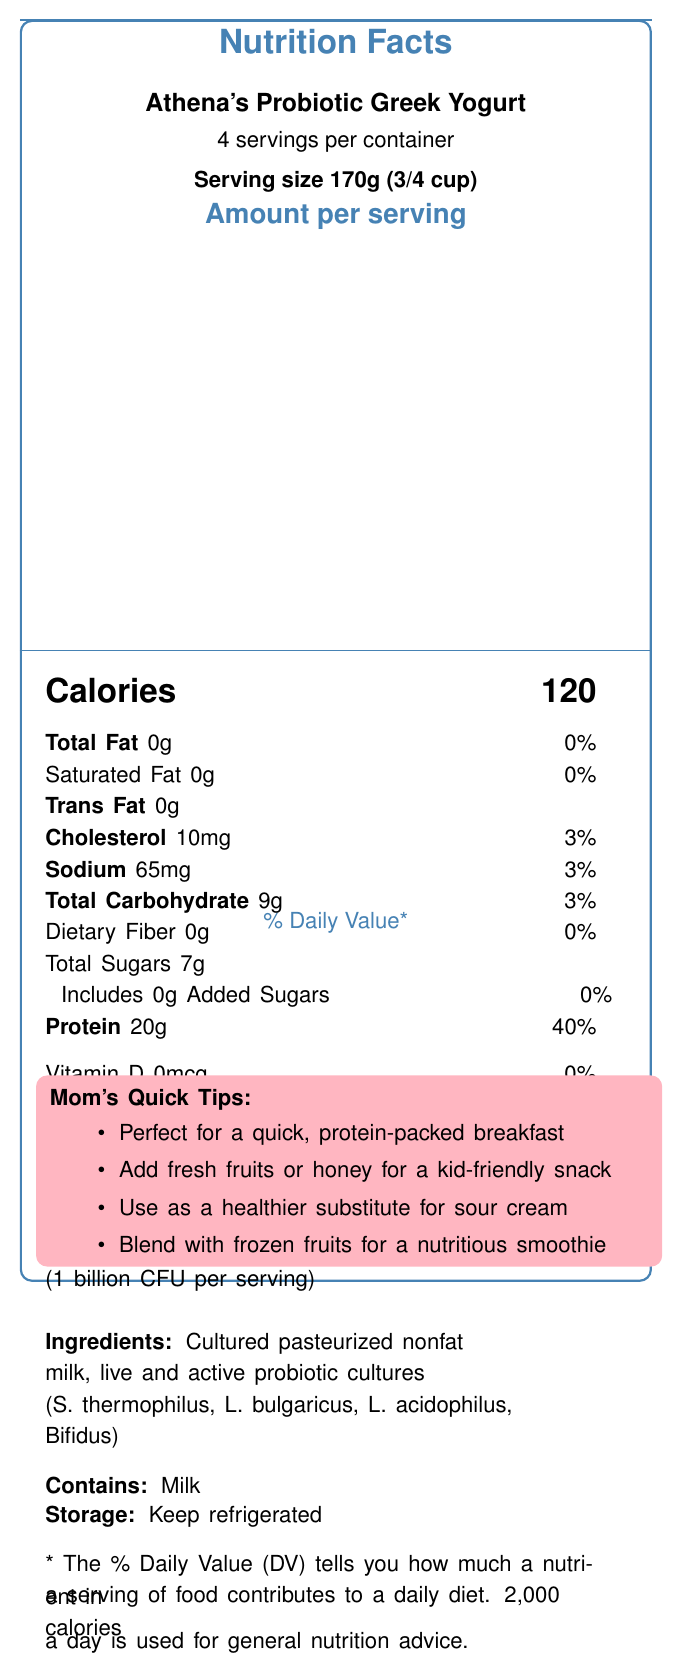what is the serving size? The document specifies "Serving size 170g (3/4 cup)" at the top.
Answer: 170g (3/4 cup) how many calories are there per serving? The document lists "Calories 120" under the "Amount per serving" section.
Answer: 120 what is the amount of protein per serving? The nutrition label states "Protein 20g" with a daily value percentage of 40%.
Answer: 20g what probiotics are included in this yogurt? The document mentions "Contains Lactobacillus acidophilus and Bifidobacterium lactis" in the probiotics section.
Answer: Lactobacillus acidophilus and Bifidobacterium lactis how much calcium is in one serving of this yogurt? The label indicates "Calcium 230mg" under the vitamins and minerals section with a 20% daily value.
Answer: 230mg does this yogurt contain any trans fat? The label clearly lists "Trans Fat 0g," indicating the yogurt does not contain trans fat.
Answer: No how much sodium is there per serving? The label shows "Sodium 65mg" with a daily value of 3%.
Answer: 65mg how many servings are in each container? The document states "4 servings per container" near the top.
Answer: 4 what are the storage instructions for this yogurt? The storage instructions are "Keep refrigerated" as specified near the bottom of the label.
Answer: Keep refrigerated what is the total carbohydrate content per serving? The document lists "Total Carbohydrate 9g" with a daily value percentage of 3%.
Answer: 9g what are some ways this yogurt can be used according to the document? A. For breakfast B. As a substitute for sour cream C. In smoothies D. All of the above The document includes tips indicating that the yogurt can be used for breakfast, as a substitute for sour cream, and in smoothies among other uses.
Answer: D what is the percentage daily value for calcium in each serving? A. 10% B. 20% C. 30% D. 40% The label specifies "Calcium 230mg" with a "20%" daily value which matches option B.
Answer: B is this yogurt suitable for people avoiding added sugars? The label indicates "Total Sugars 7g" and "Includes 0g Added Sugars," confirming it has no added sugars.
Answer: Yes can one serving of this yogurt fulfill a fifth of your daily protein needs? A. Yes, it fulfills 20% of your daily protein needs. B. No, it fulfills 40% of your daily protein needs. C. Yes, it fulfills 40% of your daily protein needs. D. No, it fulfills a tenth of your daily protein needs. The label states "Protein 20g" with a daily value of "40%", meaning it fulfills 40% of the daily protein needs.
Answer: C what are the main health claims of this yogurt? The health claims highlighted in the document are "Excellent source of protein," "Good source of calcium," "Low fat," and "No added sugars."
Answer: Excellent source of protein, good source of calcium, low fat, no added sugars what are the ingredients of this yogurt? The ingredients listed in the document are "Cultured pasteurized nonfat milk, live and active probiotic cultures (S. thermophilus, L. bulgaricus, L. acidophilus, Bifidus)."
Answer: Cultured pasteurized nonfat milk, live and active probiotic cultures (S. thermophilus, L. bulgaricus, L. acidophilus, Bifidus) is this yogurt a good source of vitamin D? The label shows "Vitamin D 0mcg" with "0%" daily value, indicating it is not a source of vitamin D.
Answer: No what is the total protein content in two servings of this yogurt? Each serving contains 20g of protein, so two servings would contain 40g of protein (20g x 2).
Answer: 40g does the label provide any information about the sugar type used in this yogurt? The label lists the total sugars and indicates no added sugars, but does not provide specifics on the type of sugars.
Answer: Not enough information summarize the main nutritional benefits of Athena's Probiotic Greek Yogurt. The summary covers protein and calcium content, lack of added sugars, presence of probiotics, and low fat, which are the main nutritional highlights of the product.
Answer: Athena's Probiotic Greek Yogurt is a low-fat, high-protein yogurt with no added sugars and beneficial probiotics. It is an excellent source of protein (20g per serving, 40% DV) and a good source of calcium (230mg per serving, 20% DV). It contains Lactobacillus acidophilus and Bifidobacterium lactis (1 billion CFU per serving). 